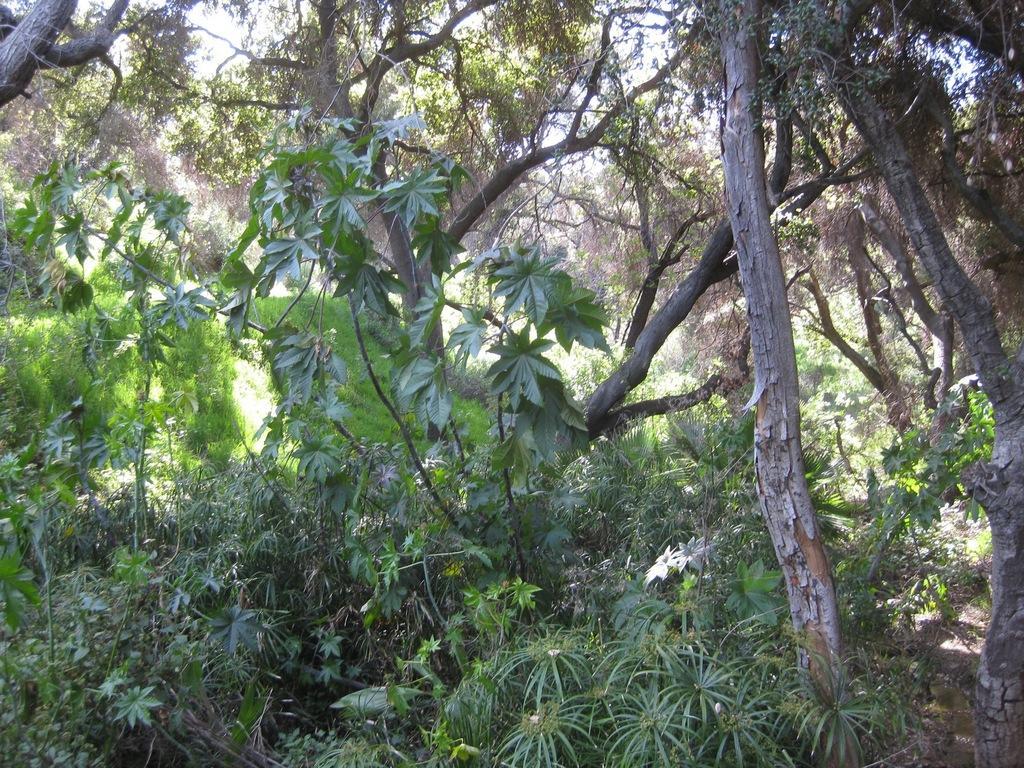Can you describe this image briefly? In the center of the image there are many trees. 